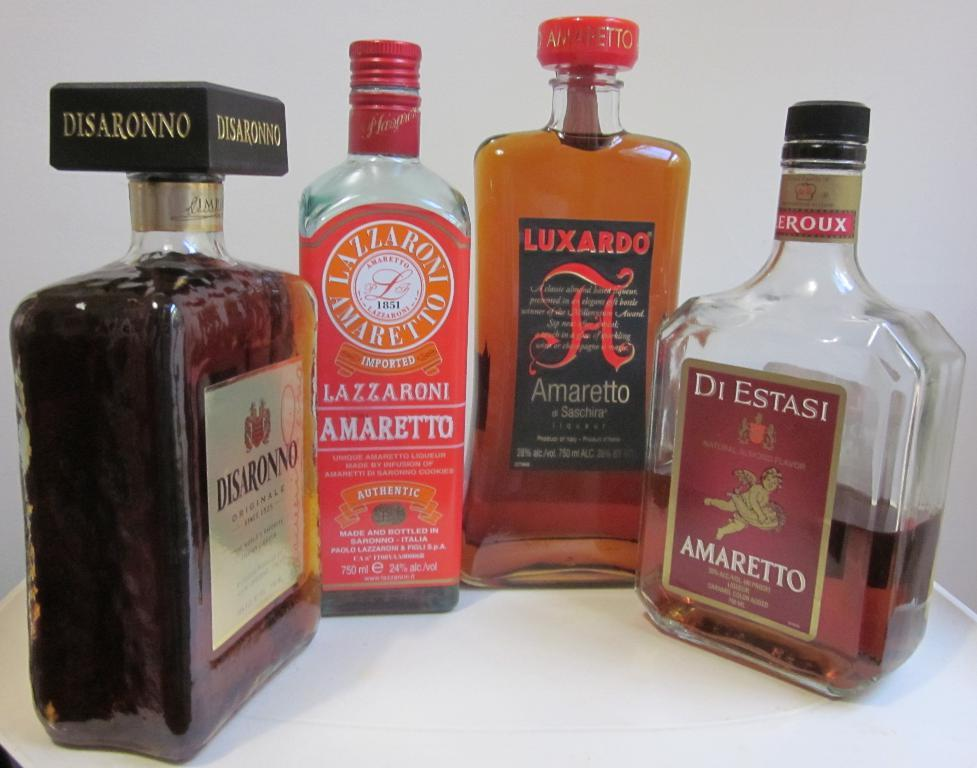<image>
Share a concise interpretation of the image provided. four bottles of liquor with one labeled 'di estasi amaretto' 